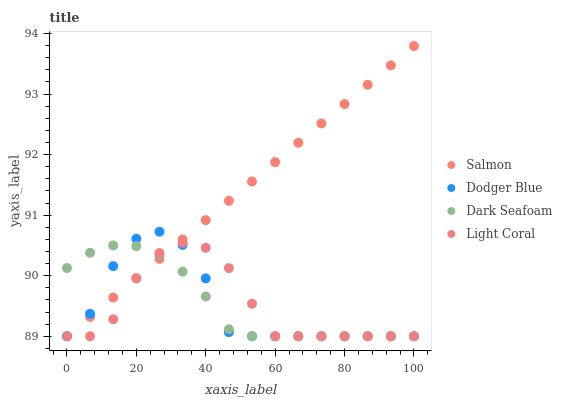Does Light Coral have the minimum area under the curve?
Answer yes or no. Yes. Does Salmon have the maximum area under the curve?
Answer yes or no. Yes. Does Dodger Blue have the minimum area under the curve?
Answer yes or no. No. Does Dodger Blue have the maximum area under the curve?
Answer yes or no. No. Is Salmon the smoothest?
Answer yes or no. Yes. Is Dodger Blue the roughest?
Answer yes or no. Yes. Is Dark Seafoam the smoothest?
Answer yes or no. No. Is Dark Seafoam the roughest?
Answer yes or no. No. Does Light Coral have the lowest value?
Answer yes or no. Yes. Does Salmon have the highest value?
Answer yes or no. Yes. Does Dodger Blue have the highest value?
Answer yes or no. No. Does Dark Seafoam intersect Salmon?
Answer yes or no. Yes. Is Dark Seafoam less than Salmon?
Answer yes or no. No. Is Dark Seafoam greater than Salmon?
Answer yes or no. No. 